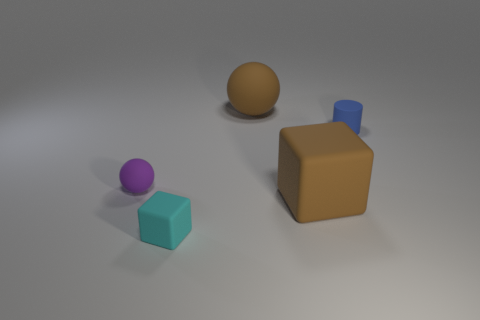Add 2 big matte cubes. How many objects exist? 7 Subtract all cylinders. How many objects are left? 4 Subtract 1 cylinders. How many cylinders are left? 0 Add 4 big objects. How many big objects exist? 6 Subtract 1 cyan blocks. How many objects are left? 4 Subtract all yellow spheres. Subtract all green blocks. How many spheres are left? 2 Subtract all cyan cylinders. How many purple blocks are left? 0 Subtract all blue rubber cylinders. Subtract all green matte cylinders. How many objects are left? 4 Add 2 brown cubes. How many brown cubes are left? 3 